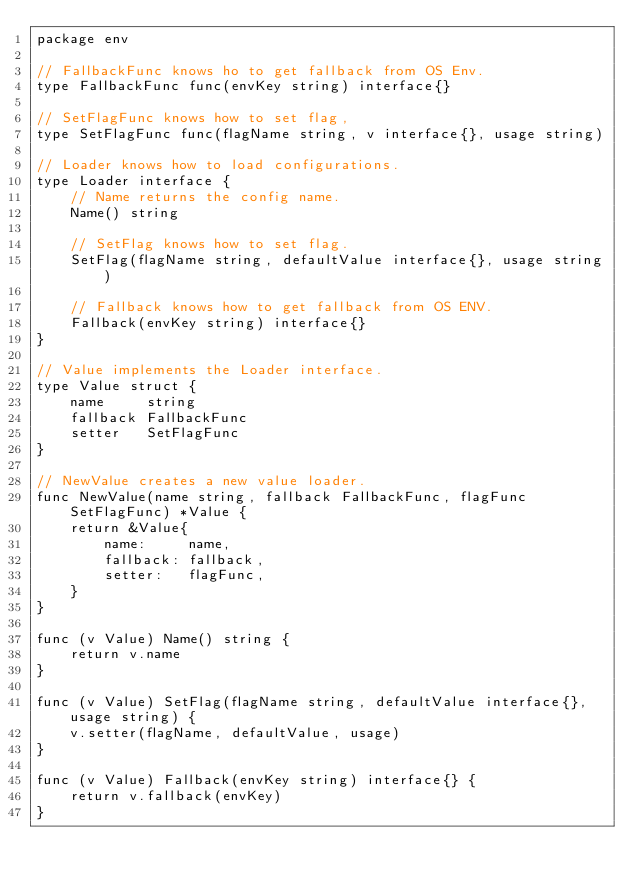<code> <loc_0><loc_0><loc_500><loc_500><_Go_>package env

// FallbackFunc knows ho to get fallback from OS Env.
type FallbackFunc func(envKey string) interface{}

// SetFlagFunc knows how to set flag,
type SetFlagFunc func(flagName string, v interface{}, usage string)

// Loader knows how to load configurations.
type Loader interface {
	// Name returns the config name.
	Name() string

	// SetFlag knows how to set flag.
	SetFlag(flagName string, defaultValue interface{}, usage string)

	// Fallback knows how to get fallback from OS ENV.
	Fallback(envKey string) interface{}
}

// Value implements the Loader interface.
type Value struct {
	name     string
	fallback FallbackFunc
	setter   SetFlagFunc
}

// NewValue creates a new value loader.
func NewValue(name string, fallback FallbackFunc, flagFunc SetFlagFunc) *Value {
	return &Value{
		name:     name,
		fallback: fallback,
		setter:   flagFunc,
	}
}

func (v Value) Name() string {
	return v.name
}

func (v Value) SetFlag(flagName string, defaultValue interface{}, usage string) {
	v.setter(flagName, defaultValue, usage)
}

func (v Value) Fallback(envKey string) interface{} {
	return v.fallback(envKey)
}
</code> 